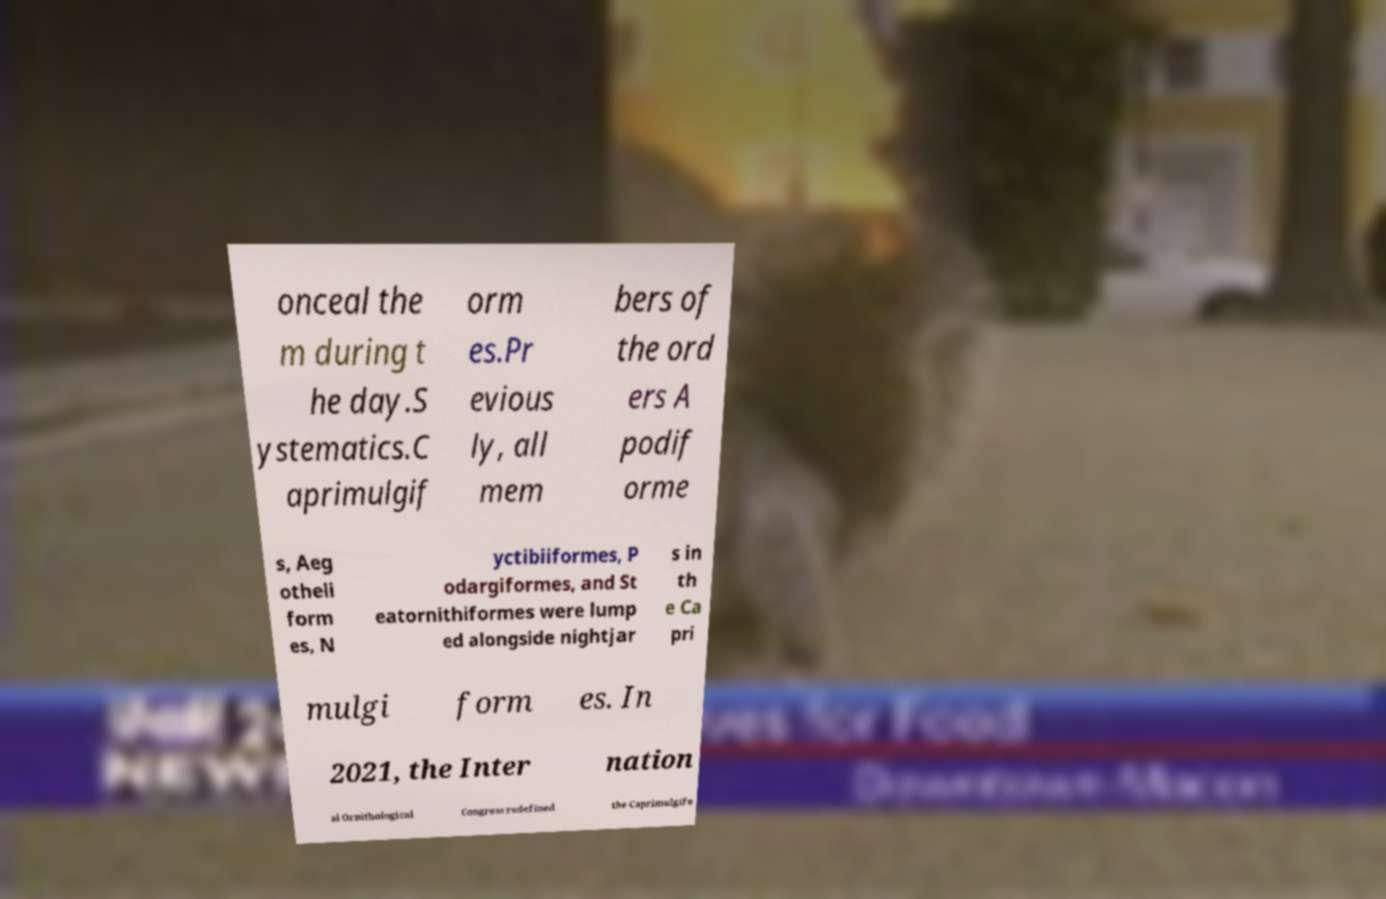Can you accurately transcribe the text from the provided image for me? onceal the m during t he day.S ystematics.C aprimulgif orm es.Pr evious ly, all mem bers of the ord ers A podif orme s, Aeg otheli form es, N yctibiiformes, P odargiformes, and St eatornithiformes were lump ed alongside nightjar s in th e Ca pri mulgi form es. In 2021, the Inter nation al Ornithological Congress redefined the Caprimulgifo 